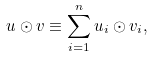Convert formula to latex. <formula><loc_0><loc_0><loc_500><loc_500>u \odot v \equiv \sum _ { i = 1 } ^ { n } u _ { i } \odot v _ { i } ,</formula> 